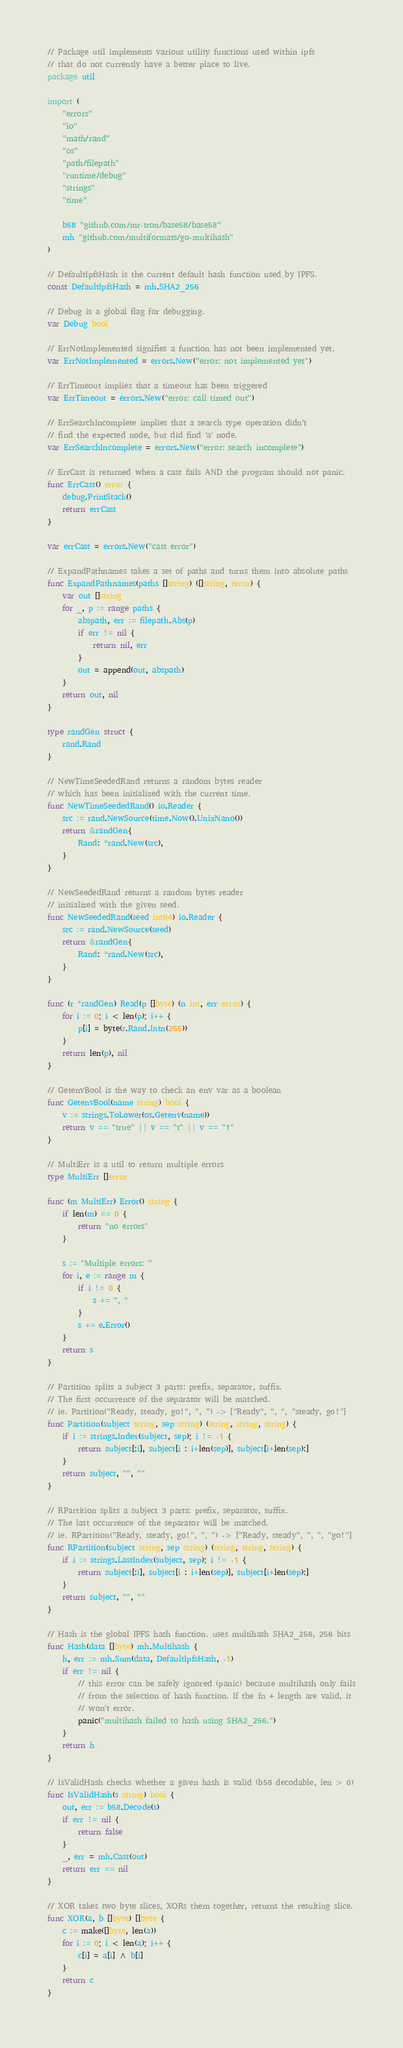Convert code to text. <code><loc_0><loc_0><loc_500><loc_500><_Go_>// Package util implements various utility functions used within ipfs
// that do not currently have a better place to live.
package util

import (
	"errors"
	"io"
	"math/rand"
	"os"
	"path/filepath"
	"runtime/debug"
	"strings"
	"time"

	b58 "github.com/mr-tron/base58/base58"
	mh "github.com/multiformats/go-multihash"
)

// DefaultIpfsHash is the current default hash function used by IPFS.
const DefaultIpfsHash = mh.SHA2_256

// Debug is a global flag for debugging.
var Debug bool

// ErrNotImplemented signifies a function has not been implemented yet.
var ErrNotImplemented = errors.New("error: not implemented yet")

// ErrTimeout implies that a timeout has been triggered
var ErrTimeout = errors.New("error: call timed out")

// ErrSearchIncomplete implies that a search type operation didn't
// find the expected node, but did find 'a' node.
var ErrSearchIncomplete = errors.New("error: search incomplete")

// ErrCast is returned when a cast fails AND the program should not panic.
func ErrCast() error {
	debug.PrintStack()
	return errCast
}

var errCast = errors.New("cast error")

// ExpandPathnames takes a set of paths and turns them into absolute paths
func ExpandPathnames(paths []string) ([]string, error) {
	var out []string
	for _, p := range paths {
		abspath, err := filepath.Abs(p)
		if err != nil {
			return nil, err
		}
		out = append(out, abspath)
	}
	return out, nil
}

type randGen struct {
	rand.Rand
}

// NewTimeSeededRand returns a random bytes reader
// which has been initialized with the current time.
func NewTimeSeededRand() io.Reader {
	src := rand.NewSource(time.Now().UnixNano())
	return &randGen{
		Rand: *rand.New(src),
	}
}

// NewSeededRand returns a random bytes reader
// initialized with the given seed.
func NewSeededRand(seed int64) io.Reader {
	src := rand.NewSource(seed)
	return &randGen{
		Rand: *rand.New(src),
	}
}

func (r *randGen) Read(p []byte) (n int, err error) {
	for i := 0; i < len(p); i++ {
		p[i] = byte(r.Rand.Intn(255))
	}
	return len(p), nil
}

// GetenvBool is the way to check an env var as a boolean
func GetenvBool(name string) bool {
	v := strings.ToLower(os.Getenv(name))
	return v == "true" || v == "t" || v == "1"
}

// MultiErr is a util to return multiple errors
type MultiErr []error

func (m MultiErr) Error() string {
	if len(m) == 0 {
		return "no errors"
	}

	s := "Multiple errors: "
	for i, e := range m {
		if i != 0 {
			s += ", "
		}
		s += e.Error()
	}
	return s
}

// Partition splits a subject 3 parts: prefix, separator, suffix.
// The first occurrence of the separator will be matched.
// ie. Partition("Ready, steady, go!", ", ") -> ["Ready", ", ", "steady, go!"]
func Partition(subject string, sep string) (string, string, string) {
	if i := strings.Index(subject, sep); i != -1 {
		return subject[:i], subject[i : i+len(sep)], subject[i+len(sep):]
	}
	return subject, "", ""
}

// RPartition splits a subject 3 parts: prefix, separator, suffix.
// The last occurrence of the separator will be matched.
// ie. RPartition("Ready, steady, go!", ", ") -> ["Ready, steady", ", ", "go!"]
func RPartition(subject string, sep string) (string, string, string) {
	if i := strings.LastIndex(subject, sep); i != -1 {
		return subject[:i], subject[i : i+len(sep)], subject[i+len(sep):]
	}
	return subject, "", ""
}

// Hash is the global IPFS hash function. uses multihash SHA2_256, 256 bits
func Hash(data []byte) mh.Multihash {
	h, err := mh.Sum(data, DefaultIpfsHash, -1)
	if err != nil {
		// this error can be safely ignored (panic) because multihash only fails
		// from the selection of hash function. If the fn + length are valid, it
		// won't error.
		panic("multihash failed to hash using SHA2_256.")
	}
	return h
}

// IsValidHash checks whether a given hash is valid (b58 decodable, len > 0)
func IsValidHash(s string) bool {
	out, err := b58.Decode(s)
	if err != nil {
		return false
	}
	_, err = mh.Cast(out)
	return err == nil
}

// XOR takes two byte slices, XORs them together, returns the resulting slice.
func XOR(a, b []byte) []byte {
	c := make([]byte, len(a))
	for i := 0; i < len(a); i++ {
		c[i] = a[i] ^ b[i]
	}
	return c
}
</code> 